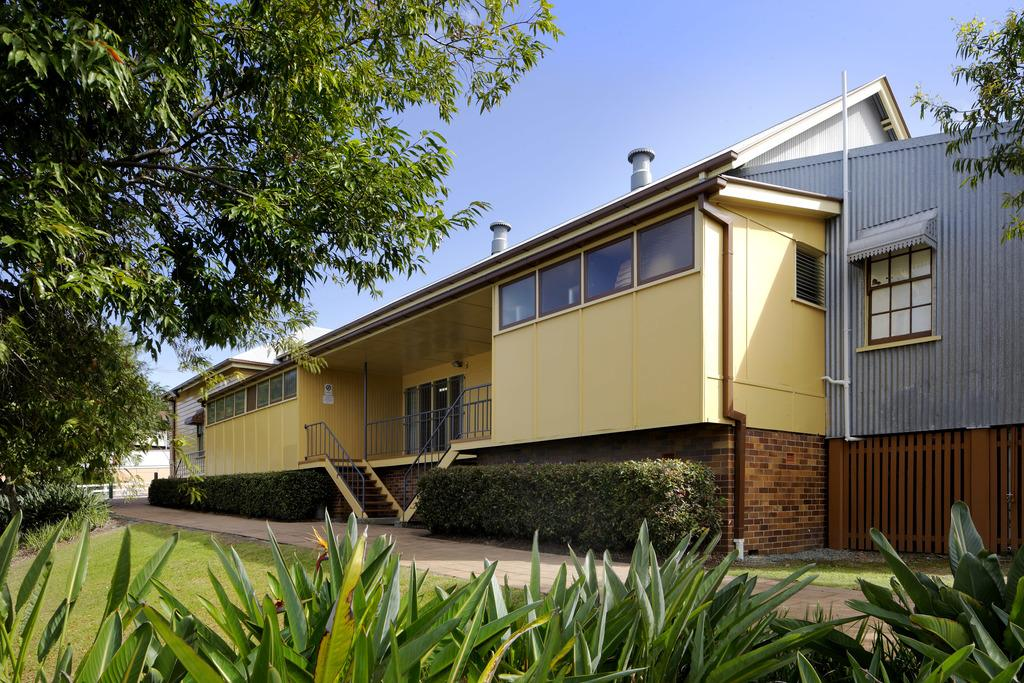What type of vegetation can be seen in the image? There is grass, plants, and trees in the image. What type of structure is present in the image? There is a house in the image. What can be seen in the background of the image? The sky is visible in the background of the image. What type of voice can be heard coming from the bear in the image? There is no bear present in the image, so it is not possible to determine what type of voice might be heard. 